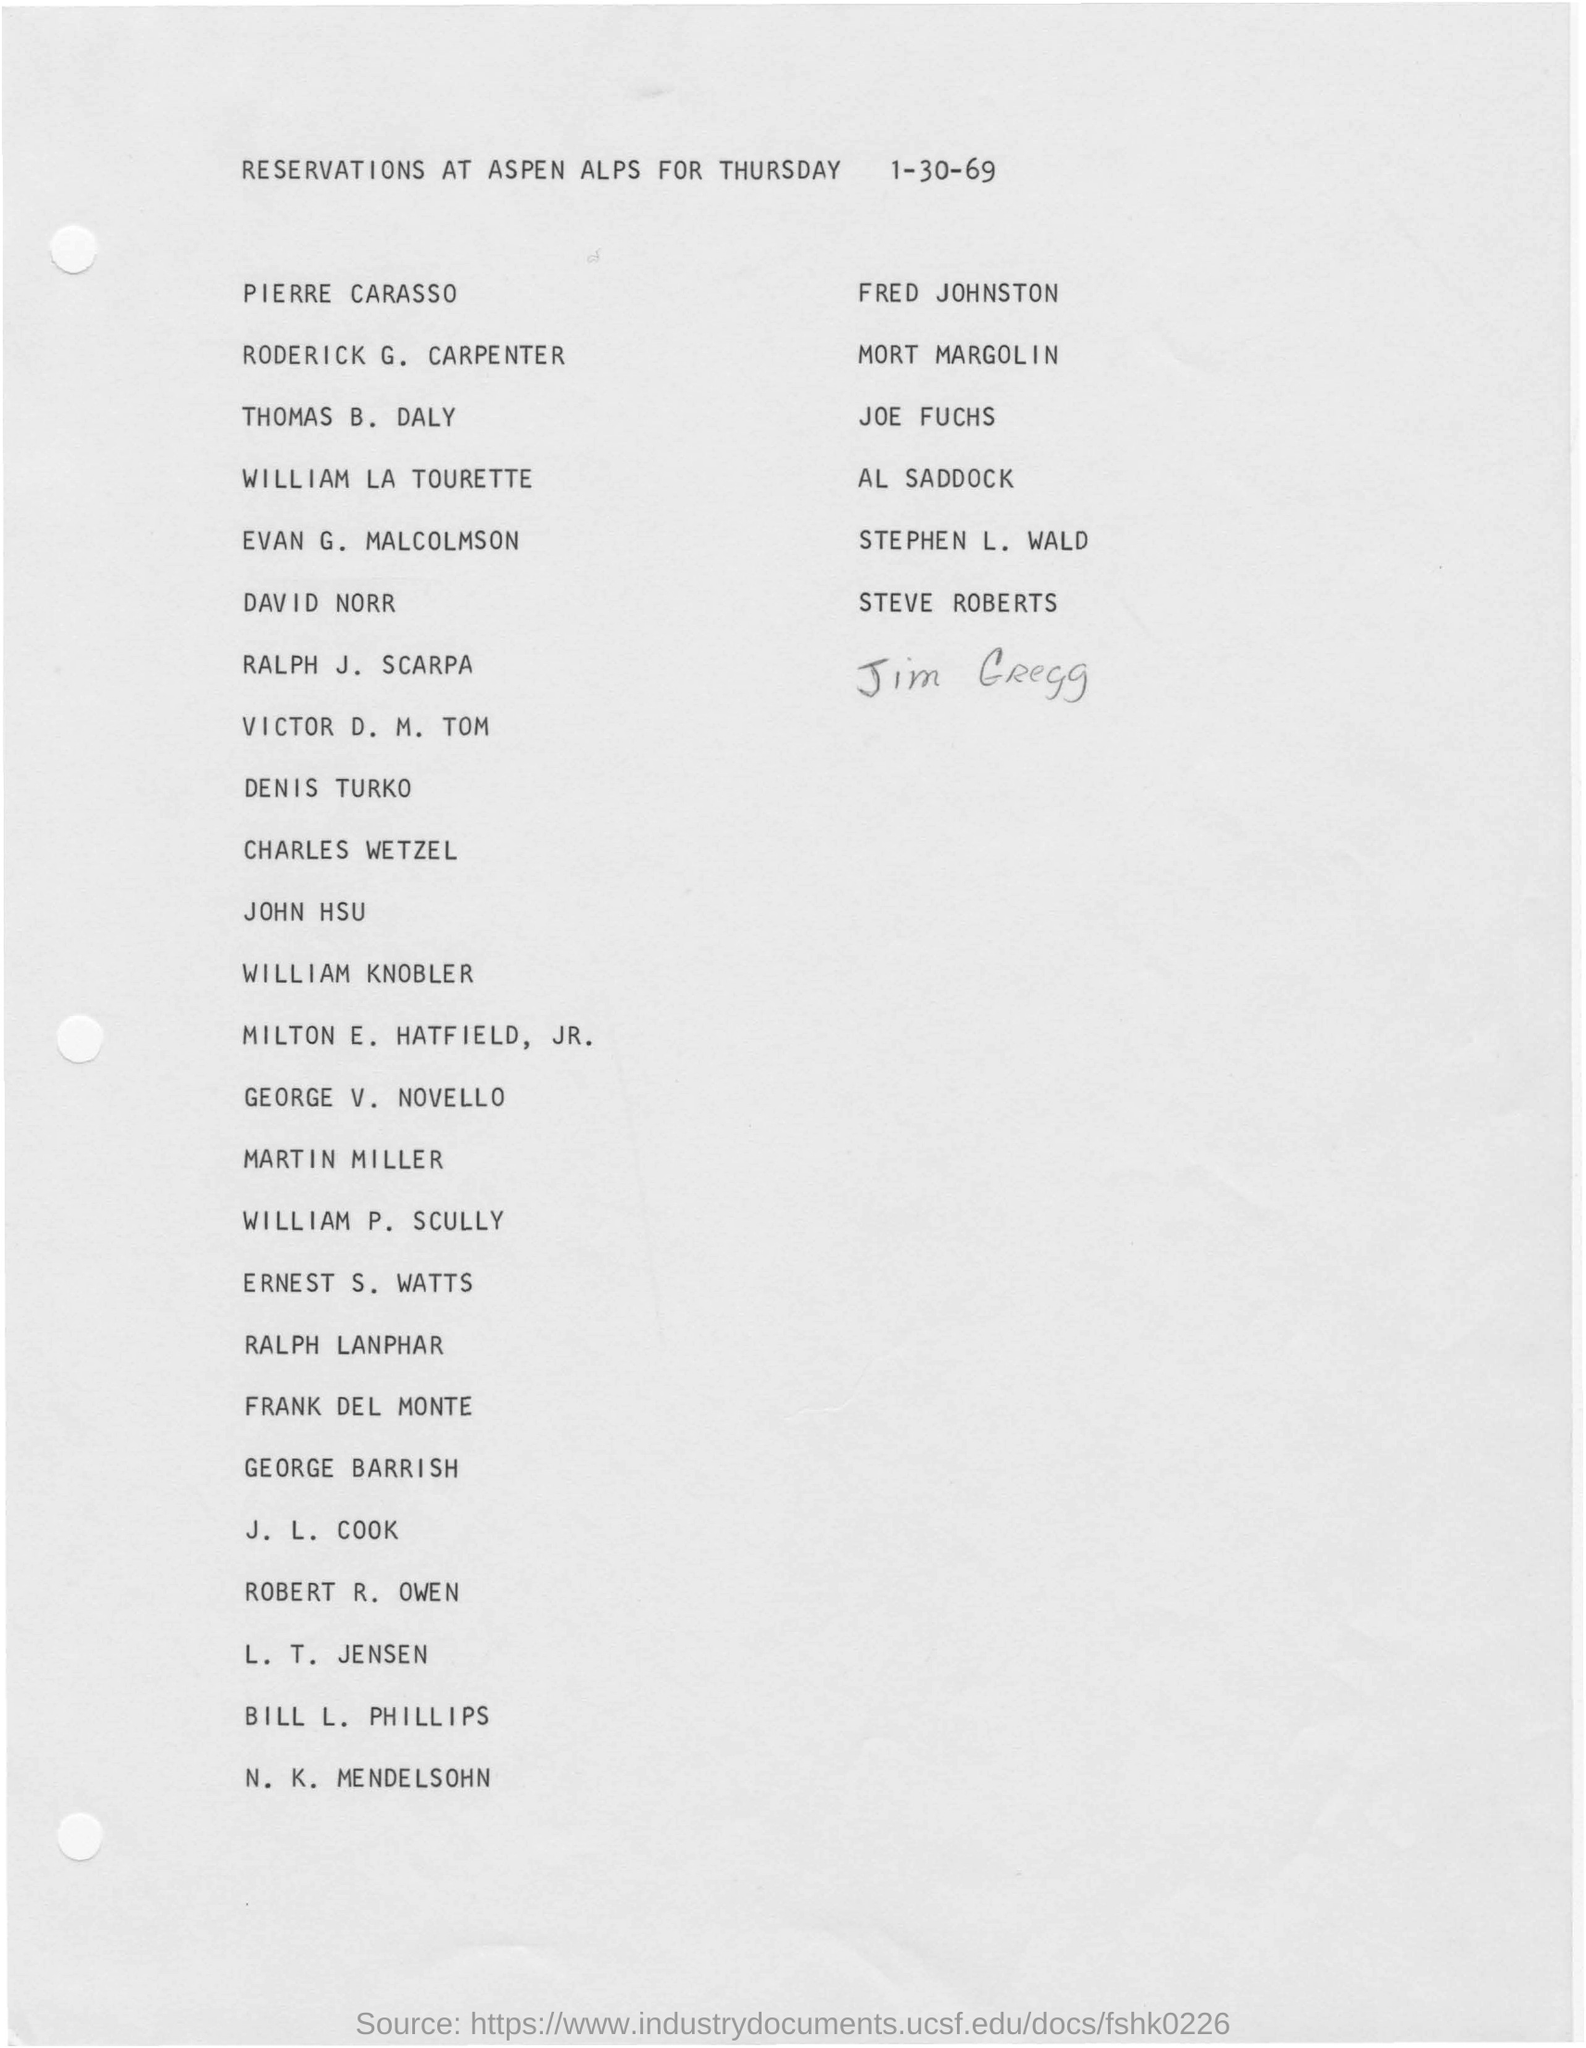Mention a couple of crucial points in this snapshot. The fourth name listed is William La Tourette. The last name added is Jim Gregg. The document is dated 1-30-69. 